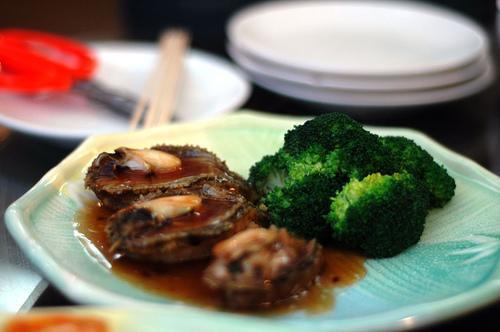How many plates are pictured?
Give a very brief answer. 5. How many skateboards are tipped up?
Give a very brief answer. 0. 